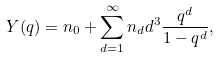Convert formula to latex. <formula><loc_0><loc_0><loc_500><loc_500>Y ( q ) = n _ { 0 } + \sum ^ { \infty } _ { d = 1 } n _ { d } d ^ { 3 } \frac { q ^ { d } } { 1 - q ^ { d } } ,</formula> 